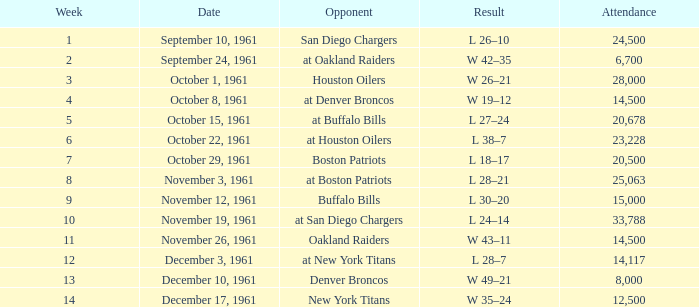What was the week with the lowest point from october 15, 1961? 5.0. 